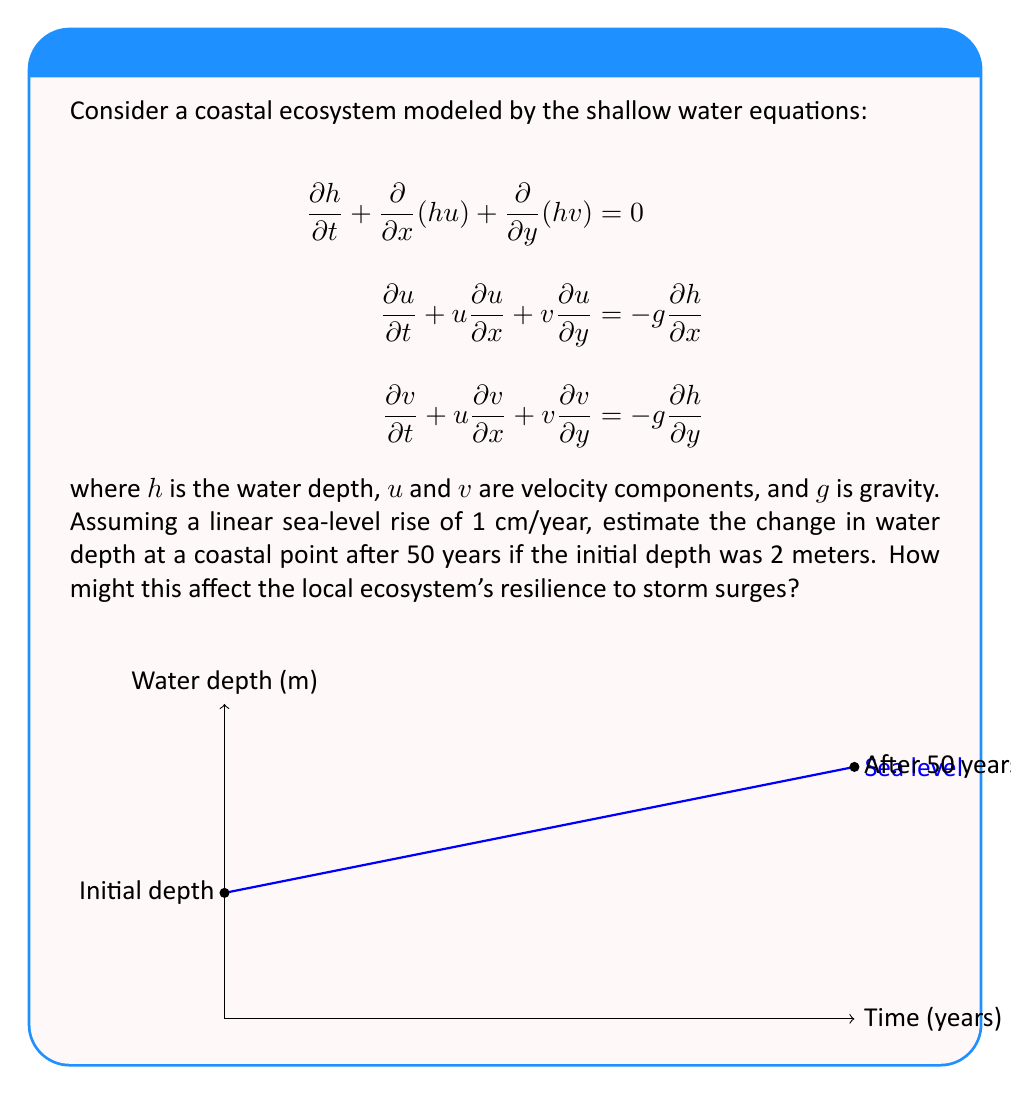What is the answer to this math problem? Let's approach this step-by-step:

1) The shallow water equations provided describe the flow dynamics in coastal areas. However, for this problem, we're focusing on the long-term change in water depth due to sea-level rise, which is given as a constant rate.

2) Given:
   - Initial depth: $h_0 = 2$ meters
   - Sea-level rise rate: $r = 1$ cm/year = 0.01 m/year
   - Time period: $t = 50$ years

3) To calculate the change in water depth, we use the linear equation:
   $$\Delta h = r \cdot t$$

4) Substituting the values:
   $$\Delta h = 0.01 \text{ m/year} \cdot 50 \text{ years} = 0.5 \text{ meters}$$

5) The new depth after 50 years will be:
   $$h_{new} = h_0 + \Delta h = 2 \text{ m} + 0.5 \text{ m} = 2.5 \text{ meters}$$

6) Impact on ecosystem resilience:
   - Increased water depth allows larger waves to reach the shore
   - Storm surges can penetrate further inland
   - Coastal habitats (e.g., mangroves, salt marshes) may be submerged
   - Erosion rates may increase
   - Saltwater intrusion into freshwater systems can occur

7) The shallow water equations become more relevant in assessing the ecosystem's resilience to storm surges:
   - Increased $h$ affects wave propagation speed ($\sqrt{gh}$)
   - Changes in $u$ and $v$ components may alter sediment transport patterns
   - Nonlinear terms ($u\frac{\partial u}{\partial x}$, etc.) become more significant with increased depth, potentially leading to more complex flow patterns during storms
Answer: Water depth increases by 0.5 m to 2.5 m; ecosystem resilience likely decreases due to larger waves, further storm surge penetration, habitat submersion, increased erosion, and saltwater intrusion. 